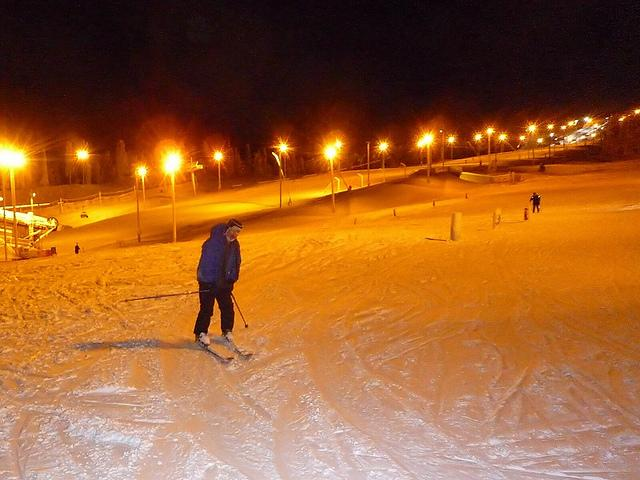Why is there so much orange in this image? lights 